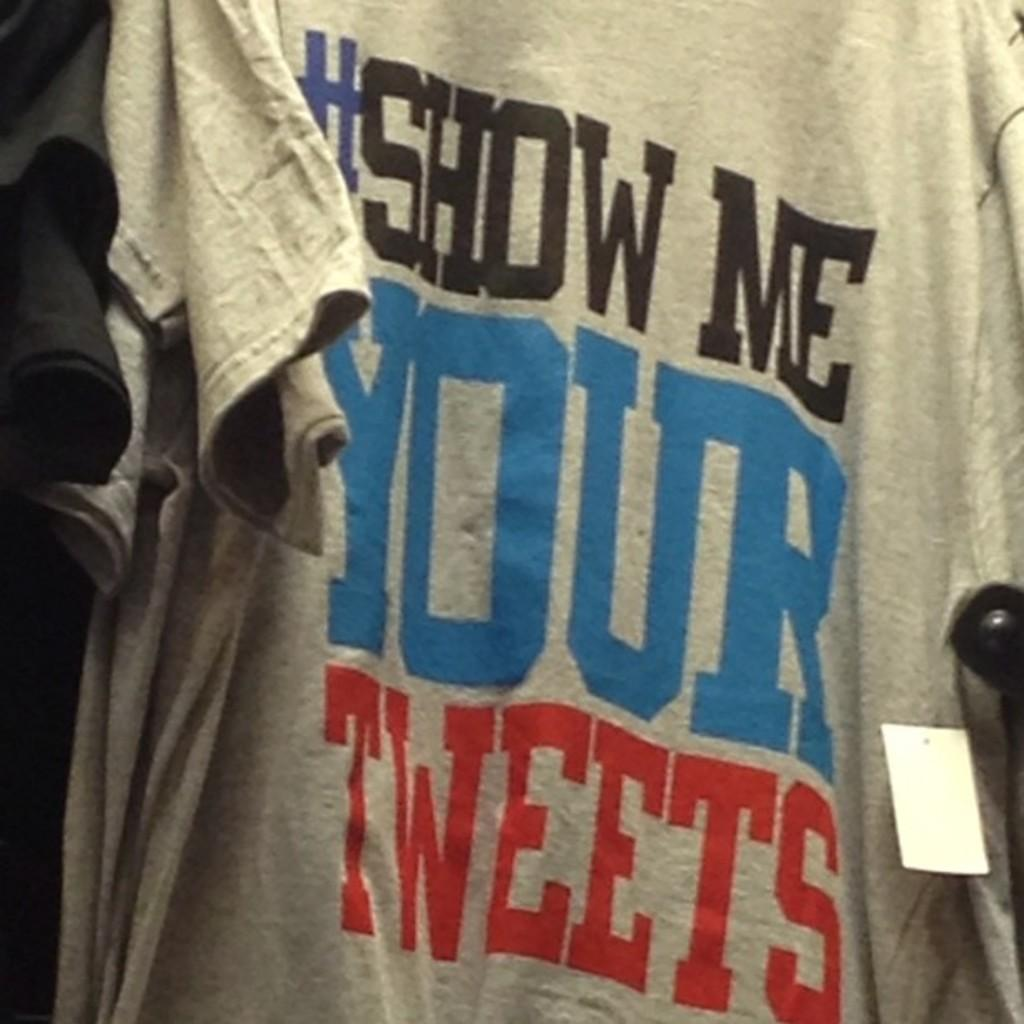<image>
Relay a brief, clear account of the picture shown. the word tweets is on a shirt that is gray 